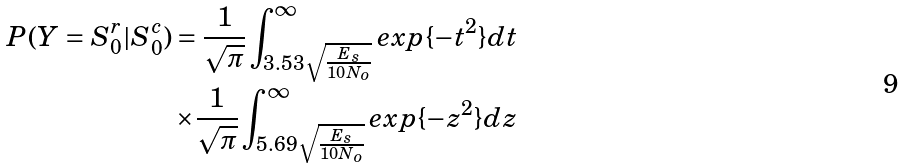Convert formula to latex. <formula><loc_0><loc_0><loc_500><loc_500>P ( Y = S _ { 0 } ^ { r } | S _ { 0 } ^ { c } ) = \frac { 1 } { \sqrt { \pi } } \int _ { 3 . 5 3 \sqrt { \frac { E _ { s } } { 1 0 N _ { o } } } } ^ { \infty } e x p \{ - t ^ { 2 } \} d t \\ \times \frac { 1 } { \sqrt { \pi } } \int _ { 5 . 6 9 \sqrt { \frac { E _ { s } } { 1 0 N _ { o } } } } ^ { \infty } e x p \{ - z ^ { 2 } \} d z</formula> 